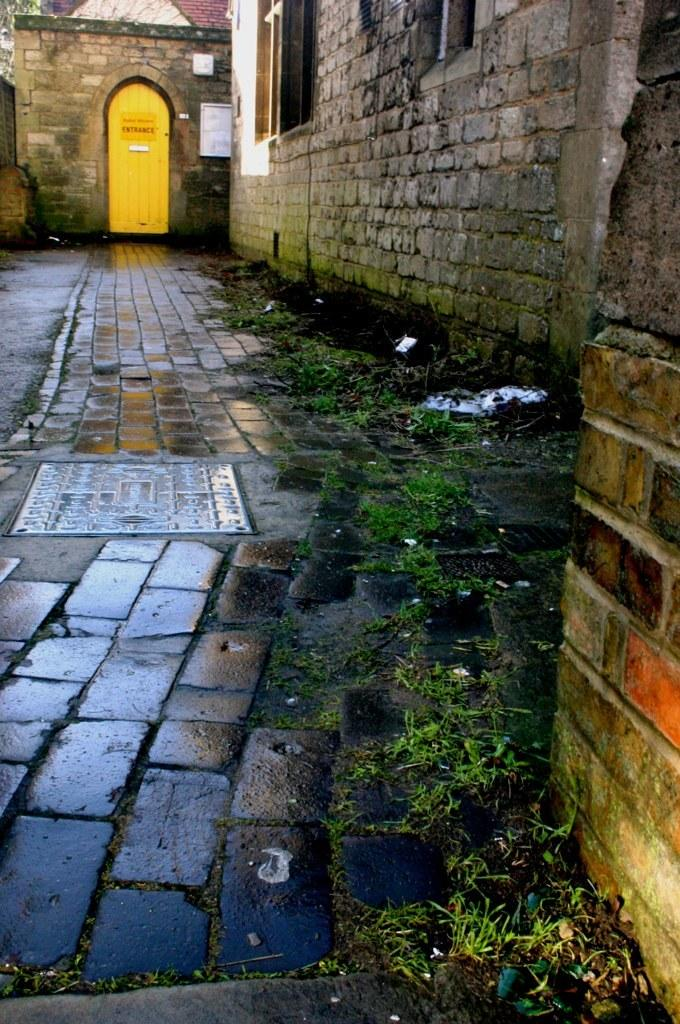What can be seen in the image that people might walk on? There is a path in the image that people might walk on. What is located on the right side of the image? There are walls on the right side of the image. What structure can be seen in the background of the image? There is a house in the background of the image. Where is the book located in the image? There is no book present in the image. Can you see any honey dripping from the walls in the image? There is no honey present in the image. 